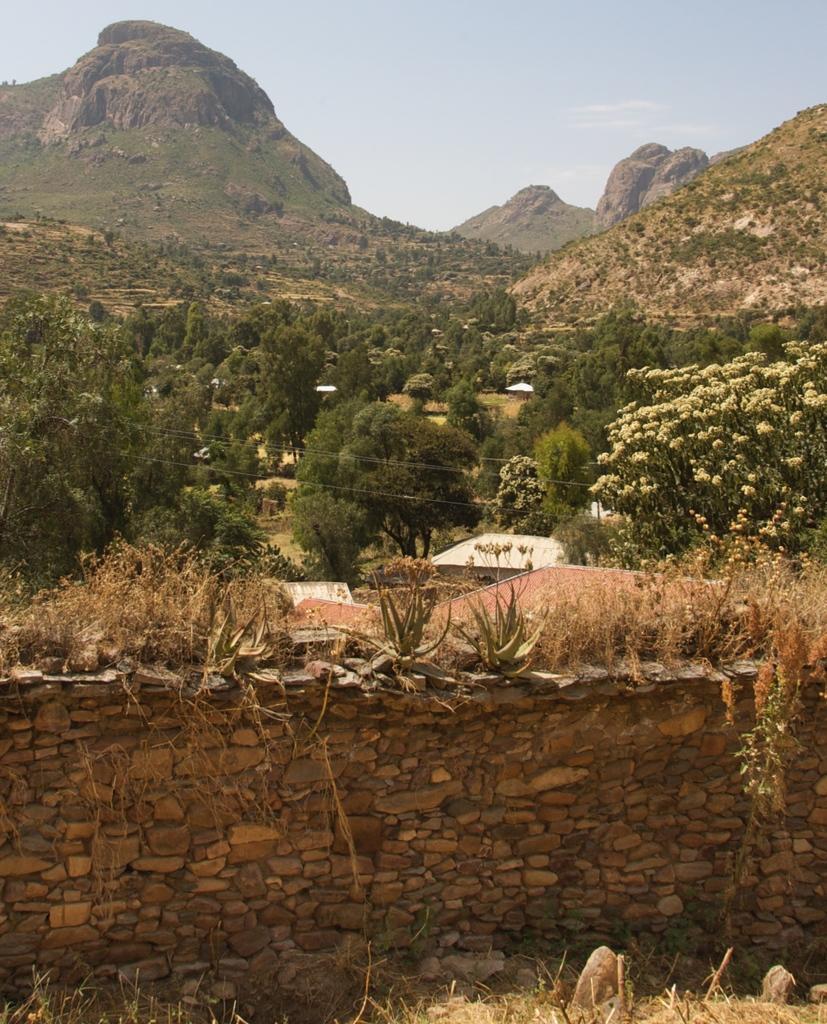How would you summarize this image in a sentence or two? In this image, I see a wall and there are plants on it. In the background I see lot of trees, a mountain and the sky. 